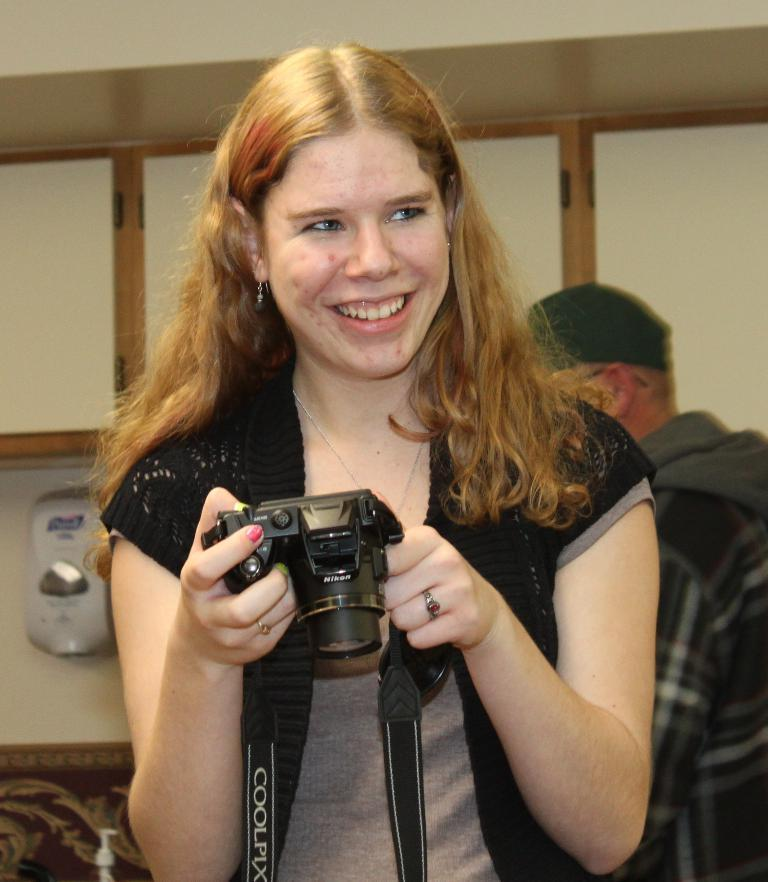Who is the main subject in the image? There is a woman in the image. What is the woman doing in the image? The woman is holding a camera with both hands. What is the woman's facial expression in the image? The woman is smiling. Can you describe the person in the background of the image? There is a person standing in the background of the image. What rule is being enforced by the woman in the image? There is no indication in the image that the woman is enforcing any rules. 